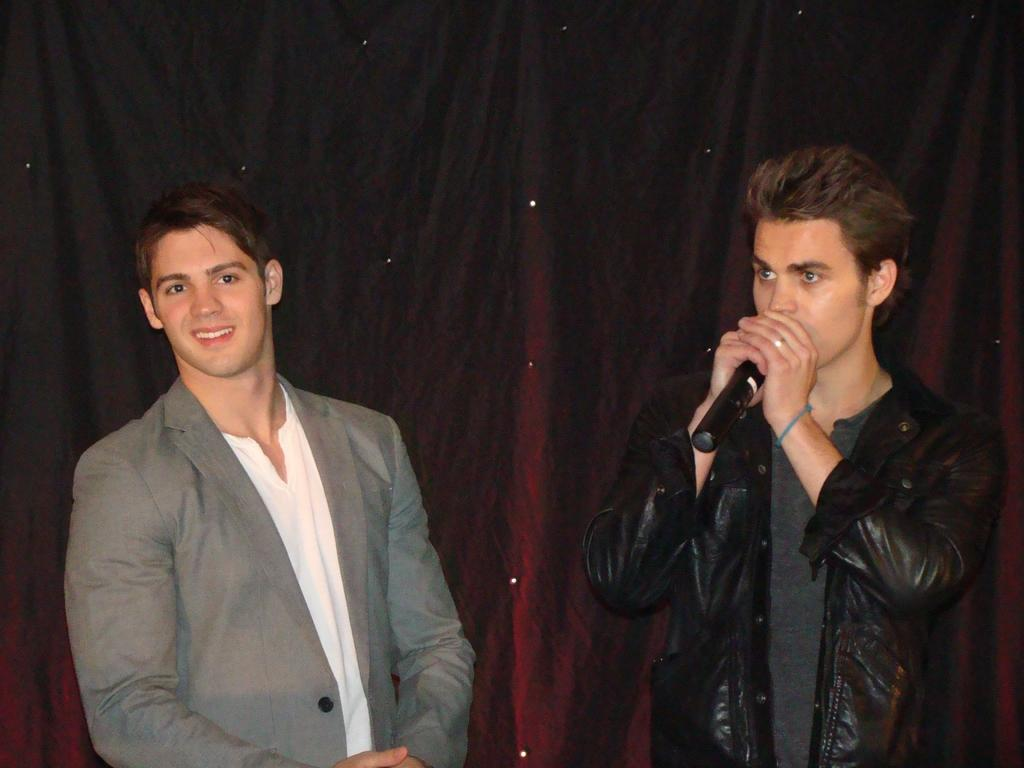How many people are in the image? There are two men standing in the image. What is the man on the left holding? The man on the left is holding a microphone in the image. What is the man with the microphone doing? The man with the microphone appears to be speaking. What type of yard can be seen in the background of the image? There is no yard visible in the image; it only shows two men, one of whom is holding a microphone. 